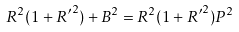<formula> <loc_0><loc_0><loc_500><loc_500>R ^ { 2 } ( 1 + { R ^ { \prime } } ^ { 2 } ) + B ^ { 2 } = R ^ { 2 } ( 1 + { R ^ { \prime } } ^ { 2 } ) P ^ { 2 }</formula> 